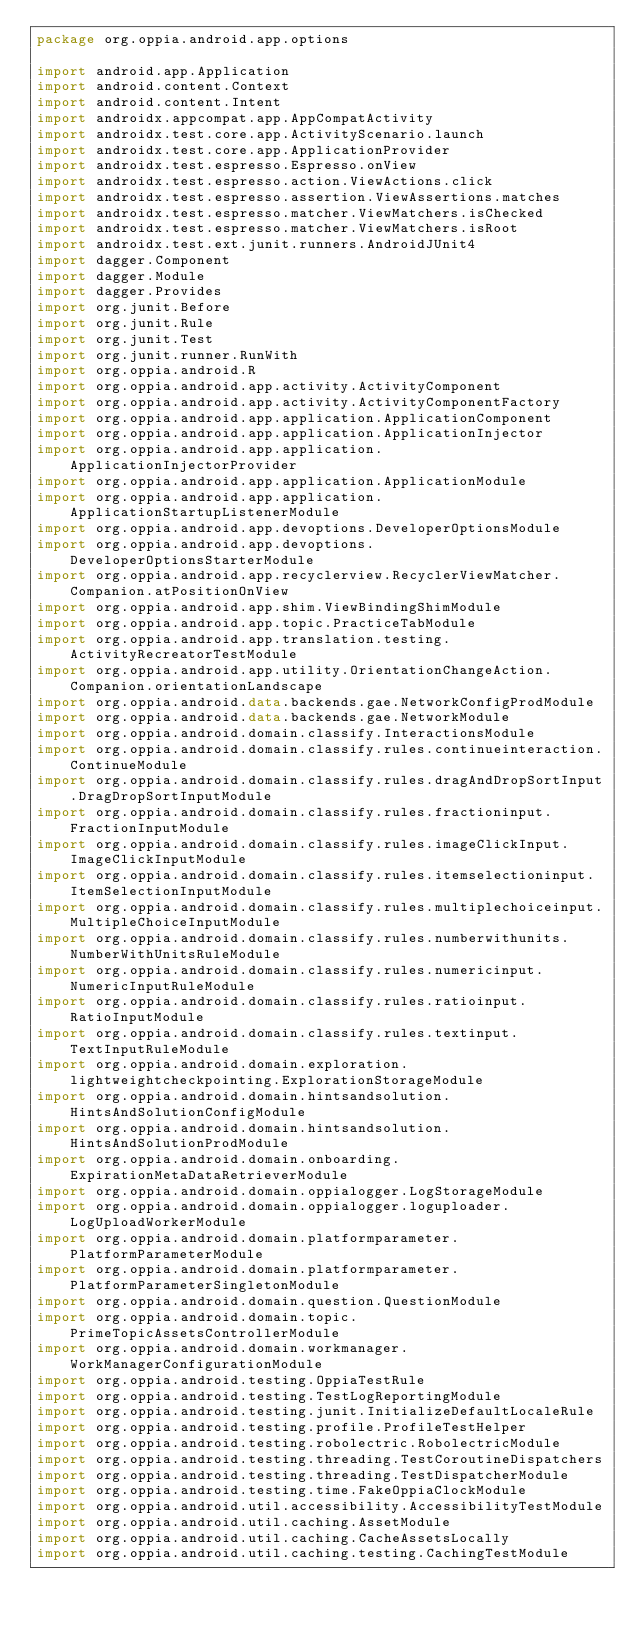Convert code to text. <code><loc_0><loc_0><loc_500><loc_500><_Kotlin_>package org.oppia.android.app.options

import android.app.Application
import android.content.Context
import android.content.Intent
import androidx.appcompat.app.AppCompatActivity
import androidx.test.core.app.ActivityScenario.launch
import androidx.test.core.app.ApplicationProvider
import androidx.test.espresso.Espresso.onView
import androidx.test.espresso.action.ViewActions.click
import androidx.test.espresso.assertion.ViewAssertions.matches
import androidx.test.espresso.matcher.ViewMatchers.isChecked
import androidx.test.espresso.matcher.ViewMatchers.isRoot
import androidx.test.ext.junit.runners.AndroidJUnit4
import dagger.Component
import dagger.Module
import dagger.Provides
import org.junit.Before
import org.junit.Rule
import org.junit.Test
import org.junit.runner.RunWith
import org.oppia.android.R
import org.oppia.android.app.activity.ActivityComponent
import org.oppia.android.app.activity.ActivityComponentFactory
import org.oppia.android.app.application.ApplicationComponent
import org.oppia.android.app.application.ApplicationInjector
import org.oppia.android.app.application.ApplicationInjectorProvider
import org.oppia.android.app.application.ApplicationModule
import org.oppia.android.app.application.ApplicationStartupListenerModule
import org.oppia.android.app.devoptions.DeveloperOptionsModule
import org.oppia.android.app.devoptions.DeveloperOptionsStarterModule
import org.oppia.android.app.recyclerview.RecyclerViewMatcher.Companion.atPositionOnView
import org.oppia.android.app.shim.ViewBindingShimModule
import org.oppia.android.app.topic.PracticeTabModule
import org.oppia.android.app.translation.testing.ActivityRecreatorTestModule
import org.oppia.android.app.utility.OrientationChangeAction.Companion.orientationLandscape
import org.oppia.android.data.backends.gae.NetworkConfigProdModule
import org.oppia.android.data.backends.gae.NetworkModule
import org.oppia.android.domain.classify.InteractionsModule
import org.oppia.android.domain.classify.rules.continueinteraction.ContinueModule
import org.oppia.android.domain.classify.rules.dragAndDropSortInput.DragDropSortInputModule
import org.oppia.android.domain.classify.rules.fractioninput.FractionInputModule
import org.oppia.android.domain.classify.rules.imageClickInput.ImageClickInputModule
import org.oppia.android.domain.classify.rules.itemselectioninput.ItemSelectionInputModule
import org.oppia.android.domain.classify.rules.multiplechoiceinput.MultipleChoiceInputModule
import org.oppia.android.domain.classify.rules.numberwithunits.NumberWithUnitsRuleModule
import org.oppia.android.domain.classify.rules.numericinput.NumericInputRuleModule
import org.oppia.android.domain.classify.rules.ratioinput.RatioInputModule
import org.oppia.android.domain.classify.rules.textinput.TextInputRuleModule
import org.oppia.android.domain.exploration.lightweightcheckpointing.ExplorationStorageModule
import org.oppia.android.domain.hintsandsolution.HintsAndSolutionConfigModule
import org.oppia.android.domain.hintsandsolution.HintsAndSolutionProdModule
import org.oppia.android.domain.onboarding.ExpirationMetaDataRetrieverModule
import org.oppia.android.domain.oppialogger.LogStorageModule
import org.oppia.android.domain.oppialogger.loguploader.LogUploadWorkerModule
import org.oppia.android.domain.platformparameter.PlatformParameterModule
import org.oppia.android.domain.platformparameter.PlatformParameterSingletonModule
import org.oppia.android.domain.question.QuestionModule
import org.oppia.android.domain.topic.PrimeTopicAssetsControllerModule
import org.oppia.android.domain.workmanager.WorkManagerConfigurationModule
import org.oppia.android.testing.OppiaTestRule
import org.oppia.android.testing.TestLogReportingModule
import org.oppia.android.testing.junit.InitializeDefaultLocaleRule
import org.oppia.android.testing.profile.ProfileTestHelper
import org.oppia.android.testing.robolectric.RobolectricModule
import org.oppia.android.testing.threading.TestCoroutineDispatchers
import org.oppia.android.testing.threading.TestDispatcherModule
import org.oppia.android.testing.time.FakeOppiaClockModule
import org.oppia.android.util.accessibility.AccessibilityTestModule
import org.oppia.android.util.caching.AssetModule
import org.oppia.android.util.caching.CacheAssetsLocally
import org.oppia.android.util.caching.testing.CachingTestModule</code> 